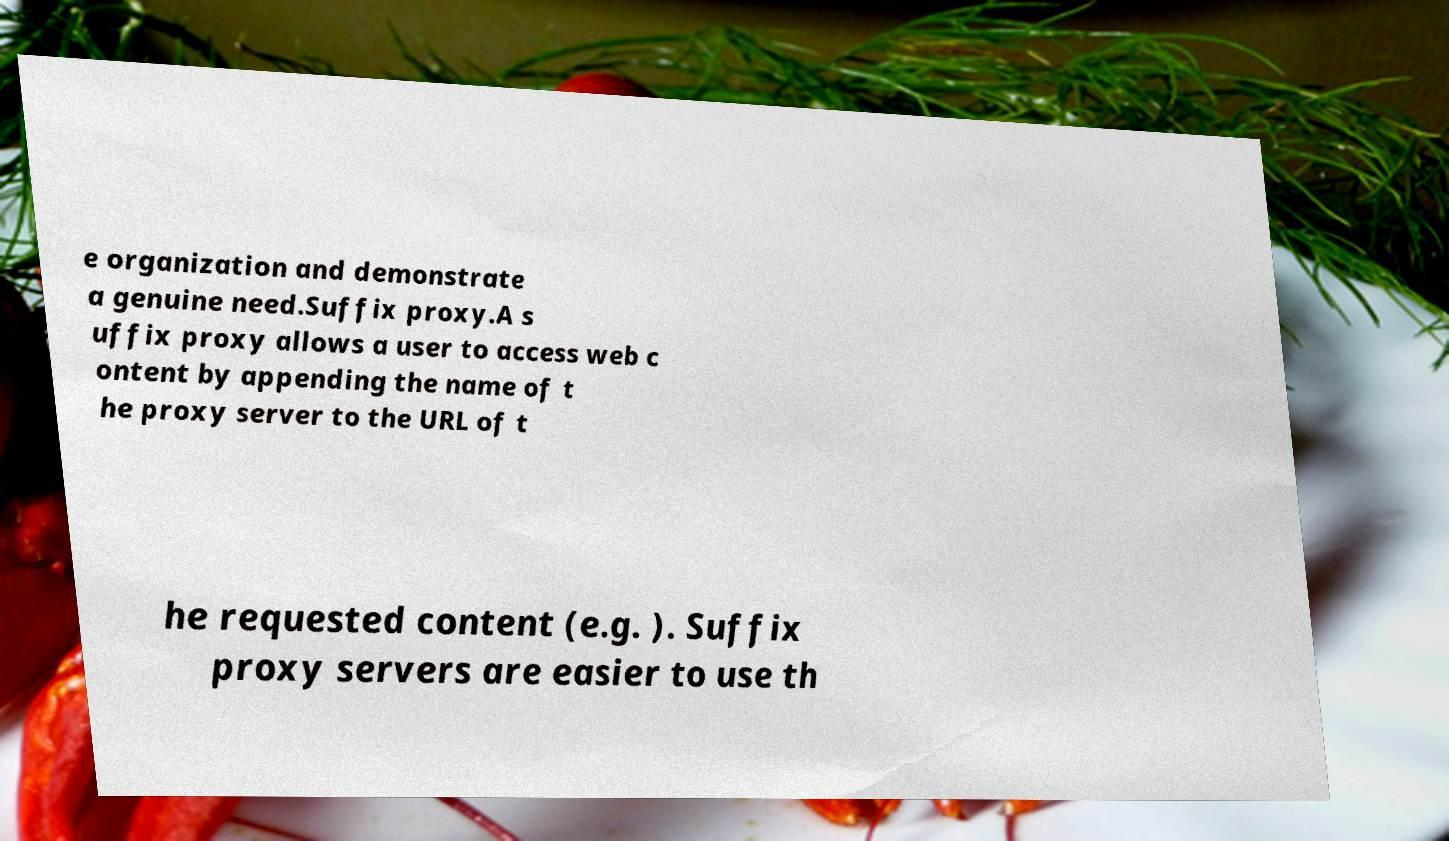What messages or text are displayed in this image? I need them in a readable, typed format. e organization and demonstrate a genuine need.Suffix proxy.A s uffix proxy allows a user to access web c ontent by appending the name of t he proxy server to the URL of t he requested content (e.g. ). Suffix proxy servers are easier to use th 